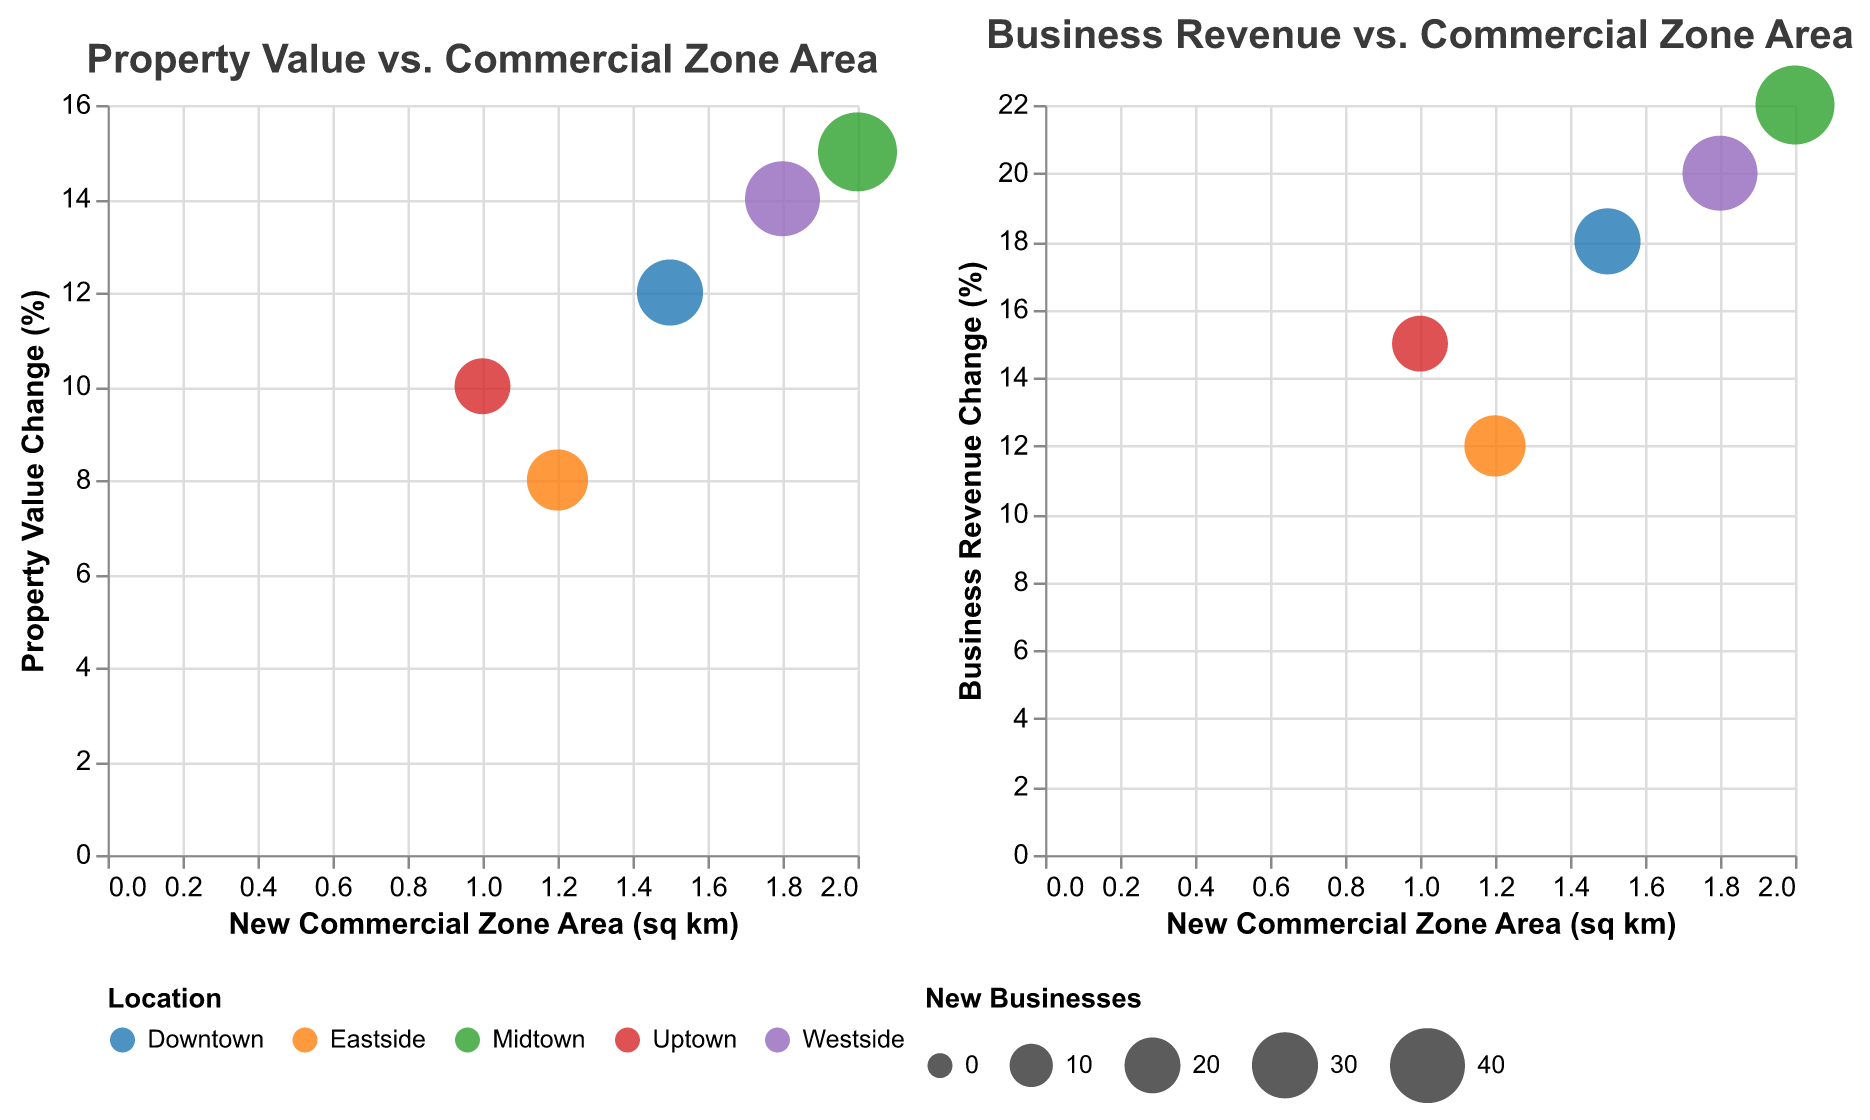What is the title of the first plot in the figure? The title can be seen directly at the top of the first plot. It reads "Property Value vs. Commercial Zone Area".
Answer: Property Value vs. Commercial Zone Area How many locations are presented in the figure? By counting the unique labels in the legend or the unique colors representing different locations, we can conclude there are five locations: Downtown, Midtown, Uptown, Eastside, and Westside.
Answer: 5 Which location has the largest bubble in the first subplot? The size of the bubble indicates the number of new businesses. By visually comparing the sizes, Midtown has the largest bubble in the first subplot.
Answer: Midtown What is the relationship between 'New Commercial Zone Area' and 'Business Revenue Change' indicated in the second subplot for Westside? For Westside, the bubble in the second subplot shows a relatively high value for both 'New Commercial Zone Area' and 'Business Revenue Change', implying they positively correlate.
Answer: Positive correlation Calculate the average 'Surrounding Property Value Change (%)' for all locations in the first subplot. Sum up all the 'Surrounding Property Value Change (%)' values (12+15+10+8+14) = 59. Divide by the number of locations (5). The average is 59/5 = 11.8%.
Answer: 11.8% Which location had the smallest increase in local business revenue according to the second plot? By observing the y-axis of the second plot, Eastside shows the smallest increase in local business revenue at 12%.
Answer: Eastside How does the 'Number of New Businesses' compare between Midtown and Eastside in the first subplot? In the first subplot, Midtown has a larger bubble size indicating 45 new businesses compared to Eastside's smaller bubble indicating 25 new businesses.
Answer: Midtown has more new businesses Is there a noticeable trend between the size of commercial zones and property values? By looking at the slope of bubbles in the first subplot, larger commercial zones tend to be associated with higher 'Property Value Change (%)', indicating a positive trend.
Answer: Positive trend Which two locations have the same year for introducing new commercial zones according to the figure? Both Downtown and Eastside introduced new commercial zones in the year 2020, as seen in the tooltip details.
Answer: Downtown and Eastside What can be inferred about the general impact of new commercial zones on local business revenues from the figure? The second subplot shows that larger commercial zones generally correspond to higher 'Local Business Revenue Change (%)', indicating new commercial zones tend to boost local business revenues.
Answer: Boost local business revenues 